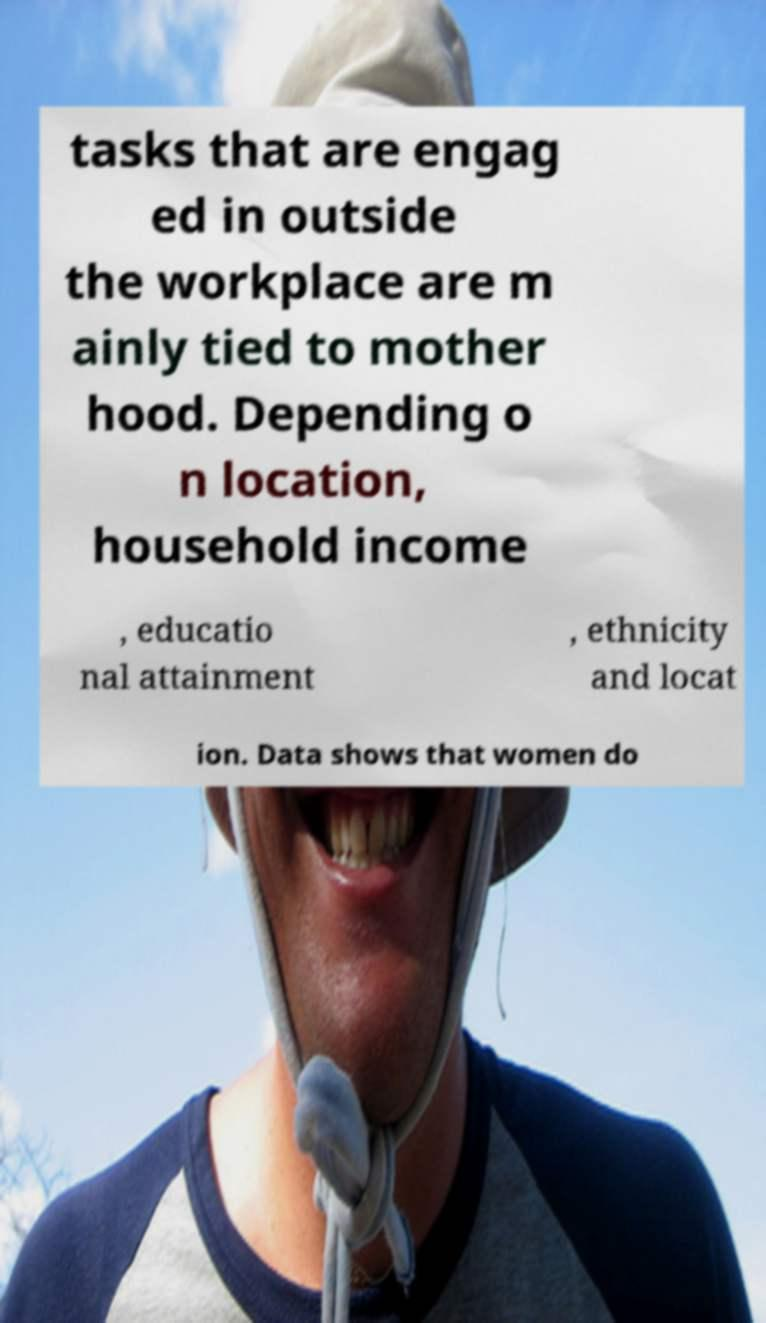Can you read and provide the text displayed in the image?This photo seems to have some interesting text. Can you extract and type it out for me? tasks that are engag ed in outside the workplace are m ainly tied to mother hood. Depending o n location, household income , educatio nal attainment , ethnicity and locat ion. Data shows that women do 